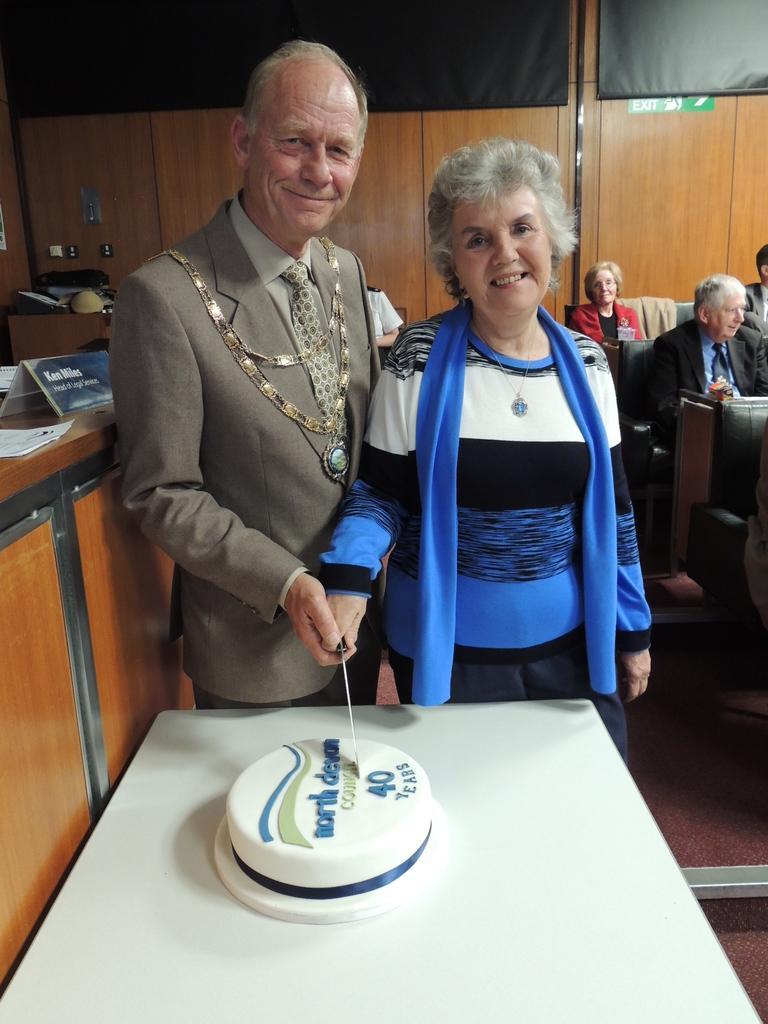Can you describe this image briefly? In this image, There is a table which is in white color, There is a cake which is in white color, There are two person hand holding a knife, In the left side a brown color desk, In the right side of the image there are some people siting on the chairs, In the background there is a yellow color wall. 